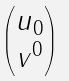Convert formula to latex. <formula><loc_0><loc_0><loc_500><loc_500>\begin{pmatrix} u _ { 0 } \\ v ^ { 0 } \end{pmatrix}</formula> 